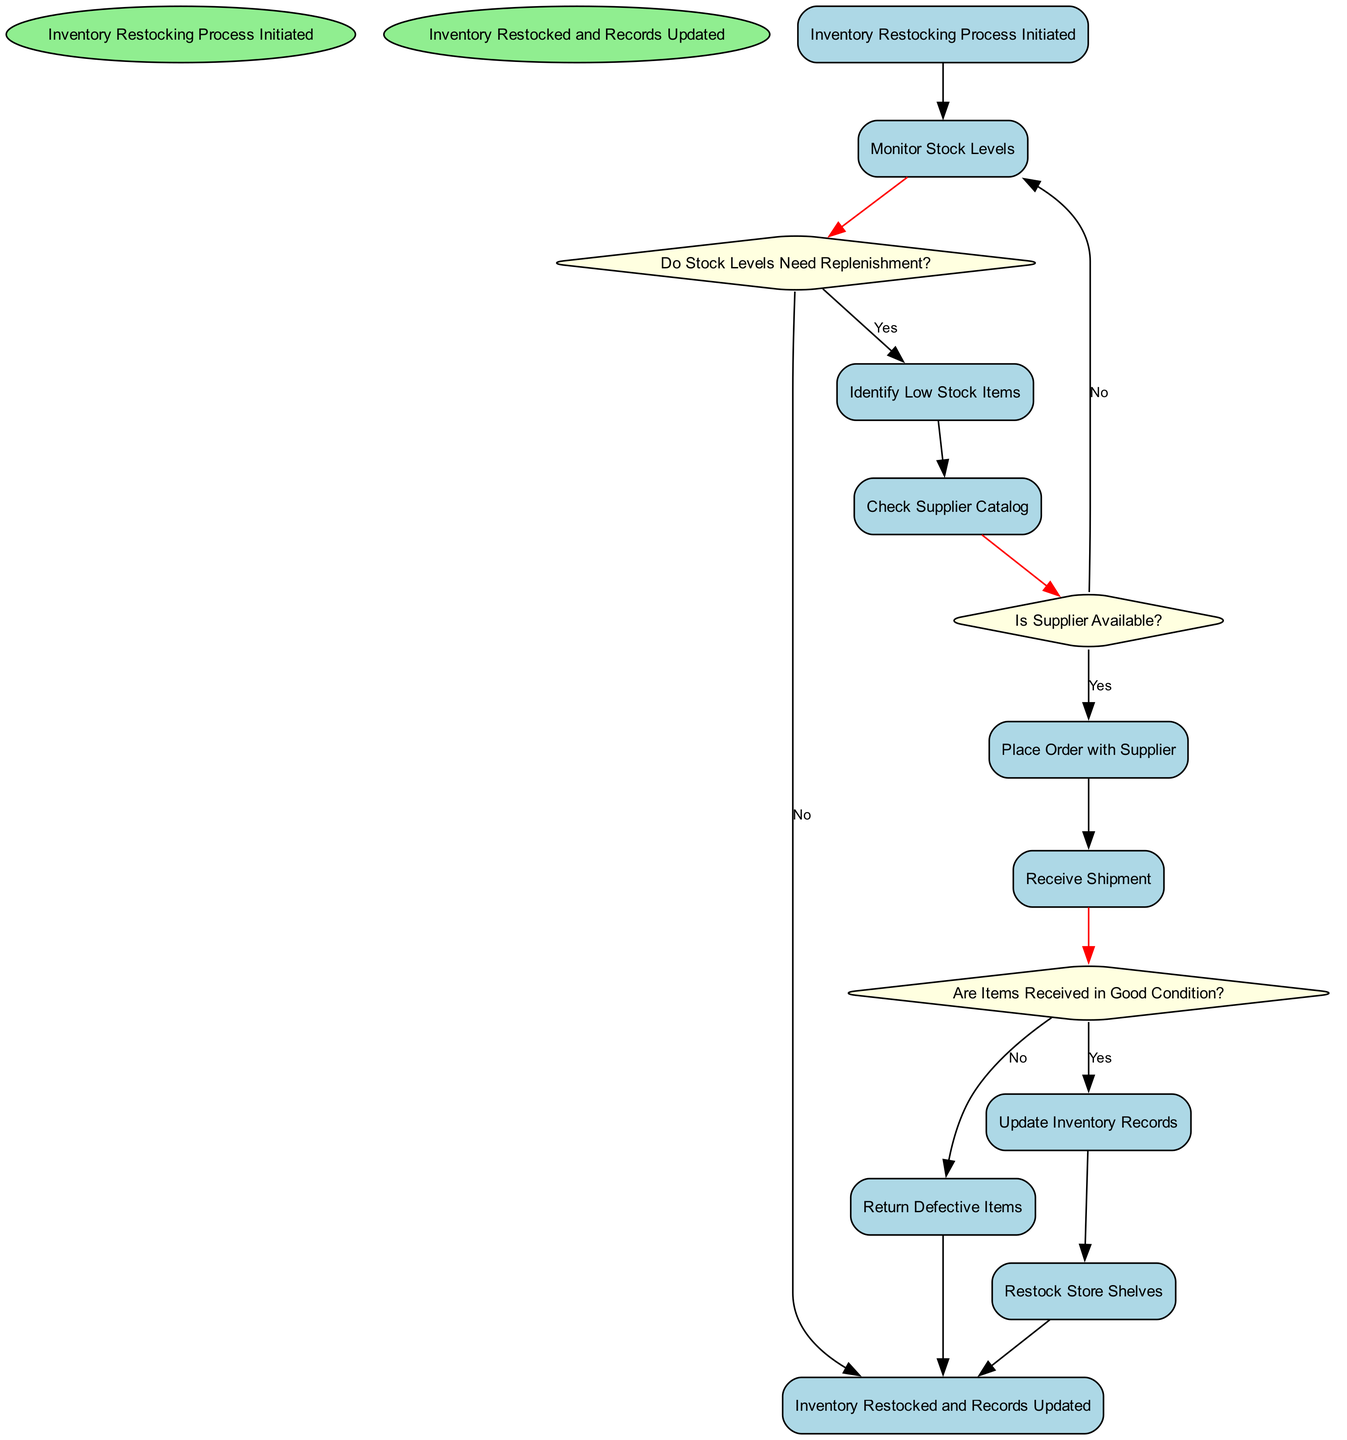What is the first activity in the workflow? The first activity is the one that comes after the "Inventory Restocking Process Initiated" node. According to the diagram, the first activity is "Monitor Stock Levels".
Answer: Monitor Stock Levels How many decision nodes are present in the diagram? By counting the nodes categorized as decisions, we can identify three decisions: "Do Stock Levels Need Replenishment?", "Is Supplier Available?", and "Are Items Received in Good Condition?". Thus, there are three decision nodes.
Answer: 3 What do you do if stock levels do not need replenishment? If the answer to "Do Stock Levels Need Replenishment?" is "No", the next step is to go directly to the end of the process, marked by "Inventory Restocked and Records Updated".
Answer: Inventory Restocked and Records Updated What happens if the supplier is not available? If the decision "Is Supplier Available?" leads to "No", the workflow does not continue to placing an order but instead loops back to "Monitor Stock Levels" for reassessment.
Answer: Monitor Stock Levels What is the last activity conducted before the workflow ends? The last activity in the diagram, just before reaching the end condition, is "Restock Store Shelves", indicating that this is the activity performed before concluding the process.
Answer: Restock Store Shelves What happens if items received are not in good condition? If the decision "Are Items Received in Good Condition?" is answered with "No", the flow then directs to "Return Defective Items", indicating a corrective action before the process can finally conclude.
Answer: Return Defective Items What is the condition to proceed from "Check Supplier Catalog" to the next activity? The flow from "Check Supplier Catalog" to "Is Supplier Available?" occurs unconditionally without any requirement, thereby allowing the process to continue to the next activity seamlessly.
Answer: None (Unconditional) 